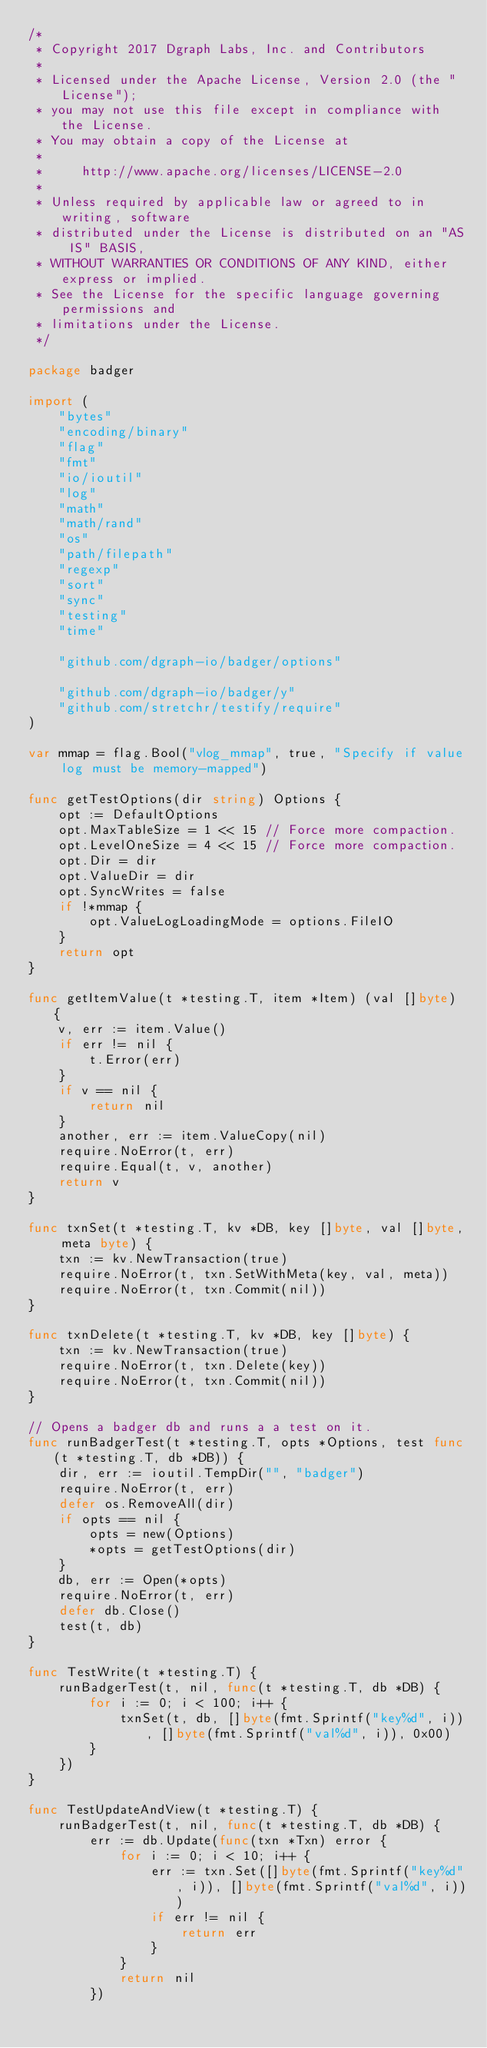<code> <loc_0><loc_0><loc_500><loc_500><_Go_>/*
 * Copyright 2017 Dgraph Labs, Inc. and Contributors
 *
 * Licensed under the Apache License, Version 2.0 (the "License");
 * you may not use this file except in compliance with the License.
 * You may obtain a copy of the License at
 *
 *     http://www.apache.org/licenses/LICENSE-2.0
 *
 * Unless required by applicable law or agreed to in writing, software
 * distributed under the License is distributed on an "AS IS" BASIS,
 * WITHOUT WARRANTIES OR CONDITIONS OF ANY KIND, either express or implied.
 * See the License for the specific language governing permissions and
 * limitations under the License.
 */

package badger

import (
	"bytes"
	"encoding/binary"
	"flag"
	"fmt"
	"io/ioutil"
	"log"
	"math"
	"math/rand"
	"os"
	"path/filepath"
	"regexp"
	"sort"
	"sync"
	"testing"
	"time"

	"github.com/dgraph-io/badger/options"

	"github.com/dgraph-io/badger/y"
	"github.com/stretchr/testify/require"
)

var mmap = flag.Bool("vlog_mmap", true, "Specify if value log must be memory-mapped")

func getTestOptions(dir string) Options {
	opt := DefaultOptions
	opt.MaxTableSize = 1 << 15 // Force more compaction.
	opt.LevelOneSize = 4 << 15 // Force more compaction.
	opt.Dir = dir
	opt.ValueDir = dir
	opt.SyncWrites = false
	if !*mmap {
		opt.ValueLogLoadingMode = options.FileIO
	}
	return opt
}

func getItemValue(t *testing.T, item *Item) (val []byte) {
	v, err := item.Value()
	if err != nil {
		t.Error(err)
	}
	if v == nil {
		return nil
	}
	another, err := item.ValueCopy(nil)
	require.NoError(t, err)
	require.Equal(t, v, another)
	return v
}

func txnSet(t *testing.T, kv *DB, key []byte, val []byte, meta byte) {
	txn := kv.NewTransaction(true)
	require.NoError(t, txn.SetWithMeta(key, val, meta))
	require.NoError(t, txn.Commit(nil))
}

func txnDelete(t *testing.T, kv *DB, key []byte) {
	txn := kv.NewTransaction(true)
	require.NoError(t, txn.Delete(key))
	require.NoError(t, txn.Commit(nil))
}

// Opens a badger db and runs a a test on it.
func runBadgerTest(t *testing.T, opts *Options, test func(t *testing.T, db *DB)) {
	dir, err := ioutil.TempDir("", "badger")
	require.NoError(t, err)
	defer os.RemoveAll(dir)
	if opts == nil {
		opts = new(Options)
		*opts = getTestOptions(dir)
	}
	db, err := Open(*opts)
	require.NoError(t, err)
	defer db.Close()
	test(t, db)
}

func TestWrite(t *testing.T) {
	runBadgerTest(t, nil, func(t *testing.T, db *DB) {
		for i := 0; i < 100; i++ {
			txnSet(t, db, []byte(fmt.Sprintf("key%d", i)), []byte(fmt.Sprintf("val%d", i)), 0x00)
		}
	})
}

func TestUpdateAndView(t *testing.T) {
	runBadgerTest(t, nil, func(t *testing.T, db *DB) {
		err := db.Update(func(txn *Txn) error {
			for i := 0; i < 10; i++ {
				err := txn.Set([]byte(fmt.Sprintf("key%d", i)), []byte(fmt.Sprintf("val%d", i)))
				if err != nil {
					return err
				}
			}
			return nil
		})</code> 